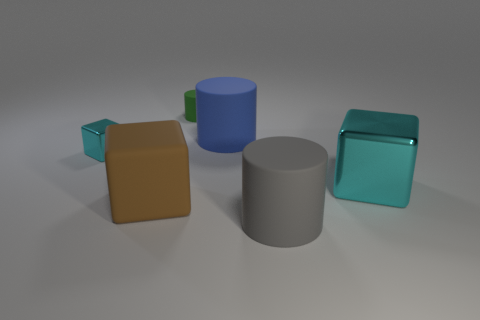What number of other objects are the same material as the tiny green cylinder?
Give a very brief answer. 3. What is the tiny cylinder made of?
Keep it short and to the point. Rubber. What number of big objects are green matte objects or gray things?
Provide a short and direct response. 1. There is a green rubber thing; how many big things are on the left side of it?
Offer a very short reply. 1. Is there a small ball that has the same color as the big shiny cube?
Keep it short and to the point. No. The cyan object that is the same size as the gray matte thing is what shape?
Offer a very short reply. Cube. What number of green things are either shiny cubes or matte things?
Your answer should be compact. 1. How many other cylinders are the same size as the gray cylinder?
Keep it short and to the point. 1. How many things are large matte blocks or metal blocks to the right of the green thing?
Give a very brief answer. 2. Does the object that is in front of the brown matte thing have the same size as the block that is behind the big shiny cube?
Your answer should be compact. No. 